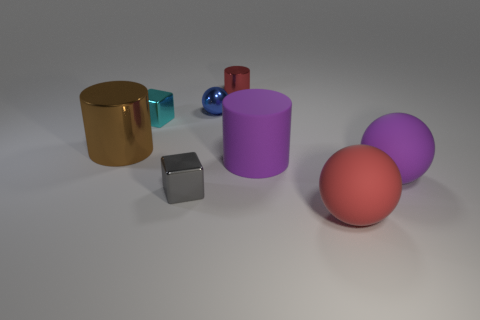Are the small cube that is in front of the purple cylinder and the thing that is behind the small blue sphere made of the same material?
Give a very brief answer. Yes. How many other small things are the same shape as the tiny blue object?
Provide a short and direct response. 0. What is the material of the big sphere that is the same color as the tiny metallic cylinder?
Give a very brief answer. Rubber. What number of things are large purple objects or balls that are in front of the blue thing?
Your response must be concise. 3. What is the material of the large purple sphere?
Your response must be concise. Rubber. There is a large purple thing that is the same shape as the small red object; what is its material?
Your answer should be very brief. Rubber. The small metallic block on the right side of the metal cube behind the purple matte cylinder is what color?
Make the answer very short. Gray. How many metal objects are either small blue things or tiny green cylinders?
Ensure brevity in your answer.  1. Does the big purple sphere have the same material as the gray thing?
Keep it short and to the point. No. What material is the cylinder that is to the left of the red object behind the tiny cyan cube?
Offer a terse response. Metal. 